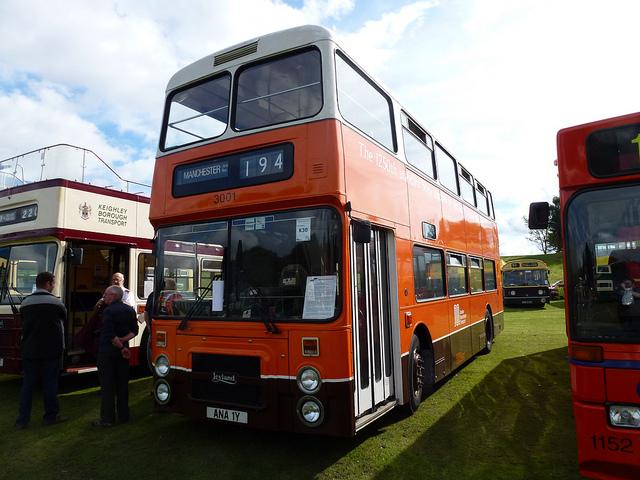What number is on the bus in the middle? 194 